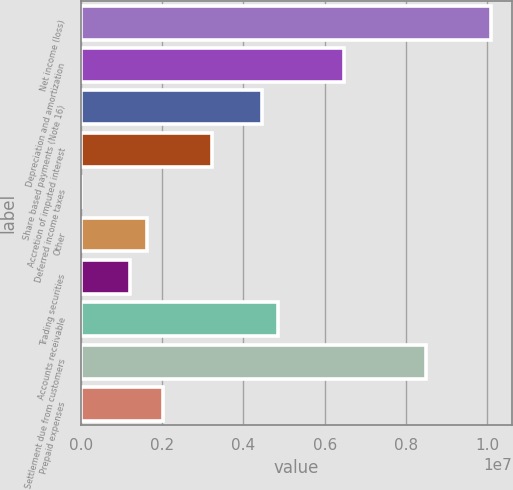Convert chart to OTSL. <chart><loc_0><loc_0><loc_500><loc_500><bar_chart><fcel>Net income (loss)<fcel>Depreciation and amortization<fcel>Share based payments (Note 16)<fcel>Accretion of imputed interest<fcel>Deferred income taxes<fcel>Other<fcel>Trading securities<fcel>Accounts receivable<fcel>Settlement due from customers<fcel>Prepaid expenses<nl><fcel>1.00968e+07<fcel>6.46392e+06<fcel>4.44566e+06<fcel>3.23471e+06<fcel>5492<fcel>1.6201e+06<fcel>1.21645e+06<fcel>4.84931e+06<fcel>8.48218e+06<fcel>2.02375e+06<nl></chart> 